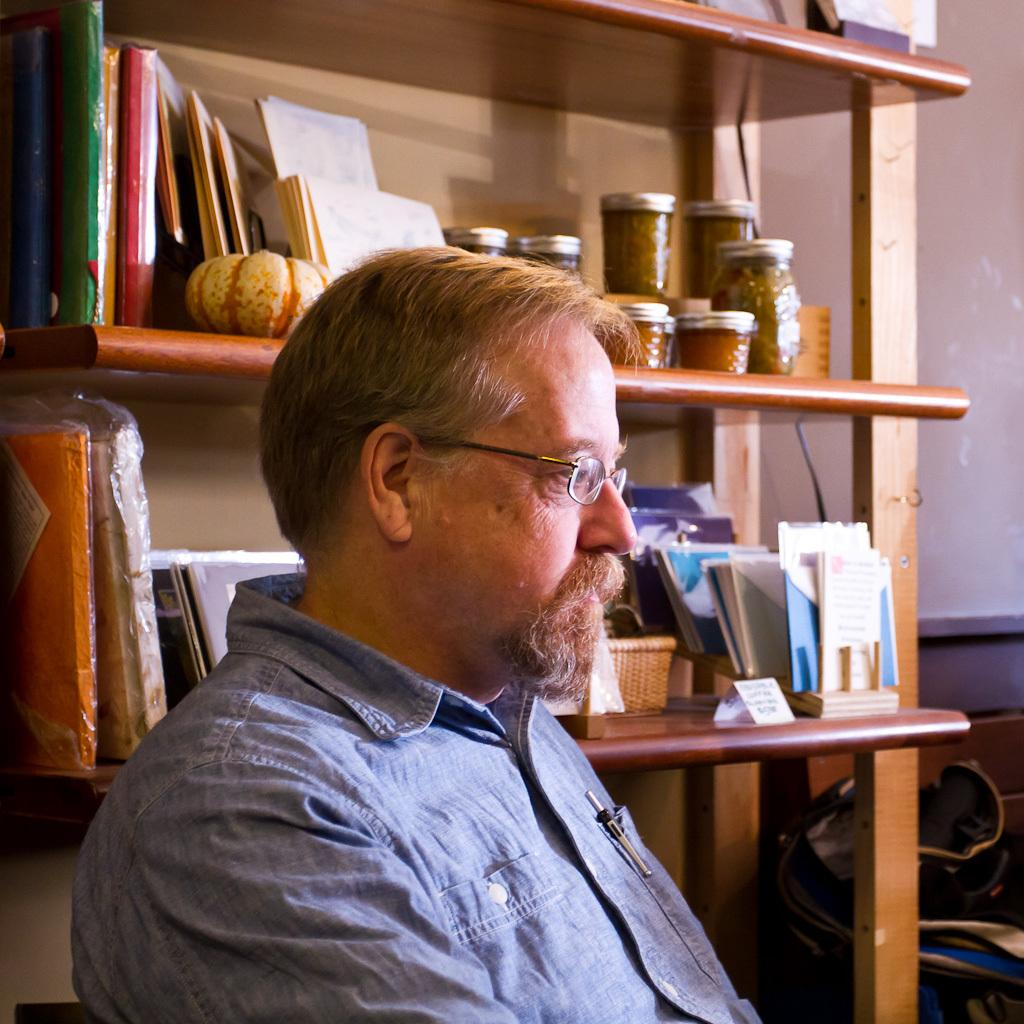What is the man in the image wearing on his face? The man is wearing spectacles in the image. What items can be seen related to reading or learning in the image? There are books and a board visible in the image. What seasonal item is present in the image? A pumpkin is present in the image. What type of container is visible in the image? A basket is visible in the image. How are objects organized in the image? Objects are present in racks in the image. What is located in the background of the image? There is a bag and a wall in the background of the image. What type of leaf is used as a sail for the ship in the image? There is no ship present in the image, so there is no sail or leaf associated with it. 